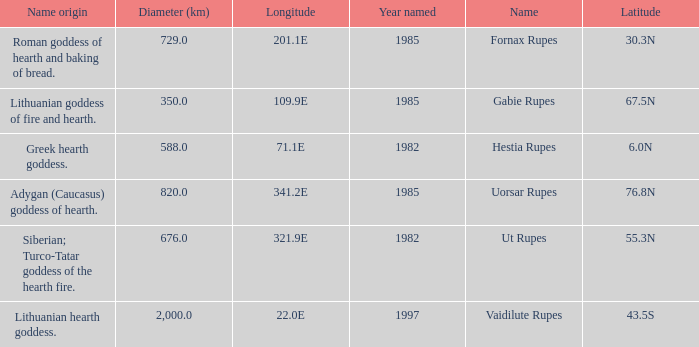At a latitude of 67.5n, what is the diameter? 350.0. 